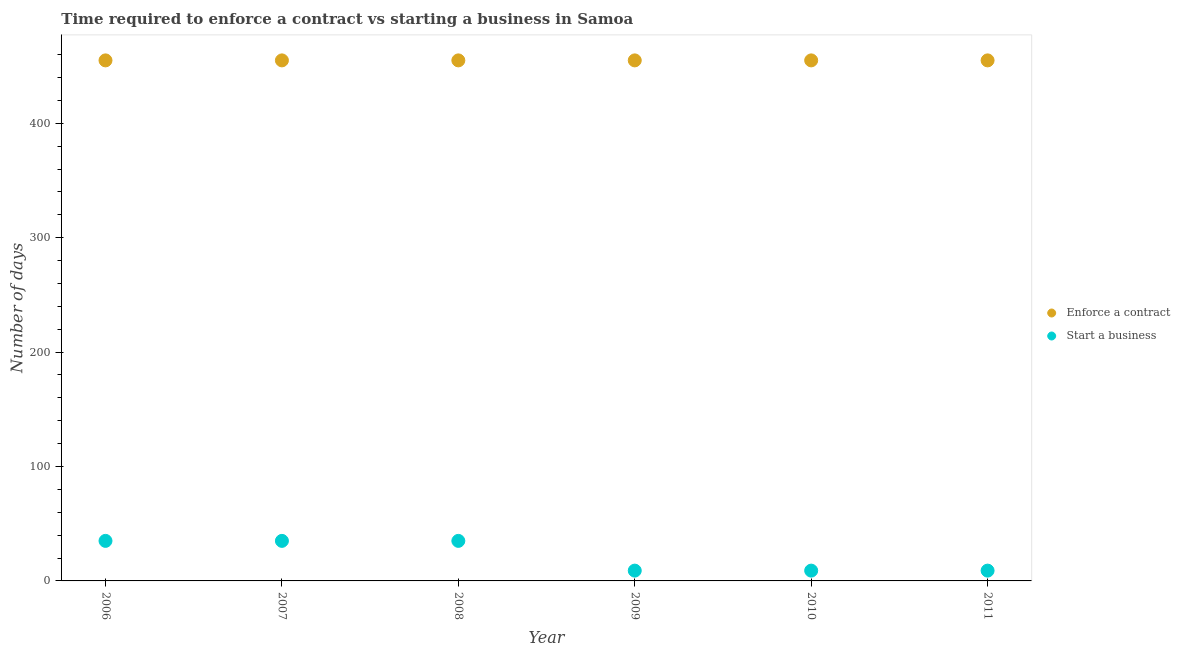How many different coloured dotlines are there?
Your answer should be compact. 2. What is the number of days to start a business in 2011?
Keep it short and to the point. 9. Across all years, what is the maximum number of days to start a business?
Your answer should be compact. 35. Across all years, what is the minimum number of days to enforece a contract?
Provide a short and direct response. 455. In which year was the number of days to enforece a contract maximum?
Provide a succinct answer. 2006. What is the total number of days to start a business in the graph?
Provide a short and direct response. 132. What is the difference between the number of days to enforece a contract in 2011 and the number of days to start a business in 2008?
Give a very brief answer. 420. What is the average number of days to start a business per year?
Your answer should be compact. 22. In the year 2010, what is the difference between the number of days to enforece a contract and number of days to start a business?
Offer a terse response. 446. Is the number of days to enforece a contract in 2009 less than that in 2011?
Your response must be concise. No. What is the difference between the highest and the second highest number of days to enforece a contract?
Provide a succinct answer. 0. What is the difference between the highest and the lowest number of days to start a business?
Give a very brief answer. 26. In how many years, is the number of days to enforece a contract greater than the average number of days to enforece a contract taken over all years?
Your answer should be compact. 0. Does the number of days to start a business monotonically increase over the years?
Your answer should be compact. No. Is the number of days to enforece a contract strictly less than the number of days to start a business over the years?
Provide a short and direct response. No. What is the difference between two consecutive major ticks on the Y-axis?
Your answer should be compact. 100. Where does the legend appear in the graph?
Provide a short and direct response. Center right. How are the legend labels stacked?
Your response must be concise. Vertical. What is the title of the graph?
Offer a very short reply. Time required to enforce a contract vs starting a business in Samoa. What is the label or title of the Y-axis?
Keep it short and to the point. Number of days. What is the Number of days of Enforce a contract in 2006?
Offer a terse response. 455. What is the Number of days in Enforce a contract in 2007?
Offer a terse response. 455. What is the Number of days in Start a business in 2007?
Offer a very short reply. 35. What is the Number of days in Enforce a contract in 2008?
Provide a succinct answer. 455. What is the Number of days of Start a business in 2008?
Make the answer very short. 35. What is the Number of days in Enforce a contract in 2009?
Offer a very short reply. 455. What is the Number of days of Enforce a contract in 2010?
Offer a terse response. 455. What is the Number of days of Start a business in 2010?
Give a very brief answer. 9. What is the Number of days of Enforce a contract in 2011?
Offer a terse response. 455. What is the Number of days in Start a business in 2011?
Provide a short and direct response. 9. Across all years, what is the maximum Number of days of Enforce a contract?
Your response must be concise. 455. Across all years, what is the maximum Number of days in Start a business?
Ensure brevity in your answer.  35. Across all years, what is the minimum Number of days in Enforce a contract?
Give a very brief answer. 455. What is the total Number of days of Enforce a contract in the graph?
Provide a short and direct response. 2730. What is the total Number of days of Start a business in the graph?
Keep it short and to the point. 132. What is the difference between the Number of days of Enforce a contract in 2006 and that in 2008?
Ensure brevity in your answer.  0. What is the difference between the Number of days of Start a business in 2006 and that in 2008?
Keep it short and to the point. 0. What is the difference between the Number of days in Start a business in 2006 and that in 2009?
Your response must be concise. 26. What is the difference between the Number of days of Enforce a contract in 2006 and that in 2010?
Ensure brevity in your answer.  0. What is the difference between the Number of days in Start a business in 2006 and that in 2010?
Your answer should be compact. 26. What is the difference between the Number of days in Enforce a contract in 2006 and that in 2011?
Your answer should be compact. 0. What is the difference between the Number of days in Enforce a contract in 2007 and that in 2008?
Your response must be concise. 0. What is the difference between the Number of days in Start a business in 2007 and that in 2008?
Provide a short and direct response. 0. What is the difference between the Number of days in Start a business in 2007 and that in 2009?
Make the answer very short. 26. What is the difference between the Number of days of Enforce a contract in 2007 and that in 2010?
Make the answer very short. 0. What is the difference between the Number of days in Enforce a contract in 2007 and that in 2011?
Offer a terse response. 0. What is the difference between the Number of days in Start a business in 2008 and that in 2009?
Your answer should be very brief. 26. What is the difference between the Number of days in Enforce a contract in 2008 and that in 2010?
Offer a very short reply. 0. What is the difference between the Number of days in Start a business in 2008 and that in 2010?
Your answer should be very brief. 26. What is the difference between the Number of days in Start a business in 2008 and that in 2011?
Your answer should be very brief. 26. What is the difference between the Number of days in Start a business in 2009 and that in 2010?
Keep it short and to the point. 0. What is the difference between the Number of days in Enforce a contract in 2010 and that in 2011?
Keep it short and to the point. 0. What is the difference between the Number of days in Enforce a contract in 2006 and the Number of days in Start a business in 2007?
Your response must be concise. 420. What is the difference between the Number of days of Enforce a contract in 2006 and the Number of days of Start a business in 2008?
Your answer should be compact. 420. What is the difference between the Number of days in Enforce a contract in 2006 and the Number of days in Start a business in 2009?
Provide a short and direct response. 446. What is the difference between the Number of days in Enforce a contract in 2006 and the Number of days in Start a business in 2010?
Your response must be concise. 446. What is the difference between the Number of days in Enforce a contract in 2006 and the Number of days in Start a business in 2011?
Give a very brief answer. 446. What is the difference between the Number of days of Enforce a contract in 2007 and the Number of days of Start a business in 2008?
Keep it short and to the point. 420. What is the difference between the Number of days in Enforce a contract in 2007 and the Number of days in Start a business in 2009?
Offer a very short reply. 446. What is the difference between the Number of days of Enforce a contract in 2007 and the Number of days of Start a business in 2010?
Give a very brief answer. 446. What is the difference between the Number of days of Enforce a contract in 2007 and the Number of days of Start a business in 2011?
Your response must be concise. 446. What is the difference between the Number of days in Enforce a contract in 2008 and the Number of days in Start a business in 2009?
Ensure brevity in your answer.  446. What is the difference between the Number of days in Enforce a contract in 2008 and the Number of days in Start a business in 2010?
Your response must be concise. 446. What is the difference between the Number of days of Enforce a contract in 2008 and the Number of days of Start a business in 2011?
Your response must be concise. 446. What is the difference between the Number of days in Enforce a contract in 2009 and the Number of days in Start a business in 2010?
Ensure brevity in your answer.  446. What is the difference between the Number of days in Enforce a contract in 2009 and the Number of days in Start a business in 2011?
Make the answer very short. 446. What is the difference between the Number of days of Enforce a contract in 2010 and the Number of days of Start a business in 2011?
Your answer should be very brief. 446. What is the average Number of days in Enforce a contract per year?
Provide a short and direct response. 455. What is the average Number of days in Start a business per year?
Provide a short and direct response. 22. In the year 2006, what is the difference between the Number of days of Enforce a contract and Number of days of Start a business?
Give a very brief answer. 420. In the year 2007, what is the difference between the Number of days of Enforce a contract and Number of days of Start a business?
Your answer should be very brief. 420. In the year 2008, what is the difference between the Number of days in Enforce a contract and Number of days in Start a business?
Provide a short and direct response. 420. In the year 2009, what is the difference between the Number of days in Enforce a contract and Number of days in Start a business?
Offer a terse response. 446. In the year 2010, what is the difference between the Number of days of Enforce a contract and Number of days of Start a business?
Keep it short and to the point. 446. In the year 2011, what is the difference between the Number of days in Enforce a contract and Number of days in Start a business?
Offer a very short reply. 446. What is the ratio of the Number of days in Start a business in 2006 to that in 2007?
Ensure brevity in your answer.  1. What is the ratio of the Number of days of Enforce a contract in 2006 to that in 2008?
Provide a succinct answer. 1. What is the ratio of the Number of days in Enforce a contract in 2006 to that in 2009?
Your answer should be very brief. 1. What is the ratio of the Number of days in Start a business in 2006 to that in 2009?
Ensure brevity in your answer.  3.89. What is the ratio of the Number of days in Enforce a contract in 2006 to that in 2010?
Make the answer very short. 1. What is the ratio of the Number of days in Start a business in 2006 to that in 2010?
Provide a succinct answer. 3.89. What is the ratio of the Number of days in Start a business in 2006 to that in 2011?
Ensure brevity in your answer.  3.89. What is the ratio of the Number of days of Enforce a contract in 2007 to that in 2008?
Offer a terse response. 1. What is the ratio of the Number of days in Start a business in 2007 to that in 2008?
Make the answer very short. 1. What is the ratio of the Number of days in Enforce a contract in 2007 to that in 2009?
Your answer should be very brief. 1. What is the ratio of the Number of days of Start a business in 2007 to that in 2009?
Ensure brevity in your answer.  3.89. What is the ratio of the Number of days in Enforce a contract in 2007 to that in 2010?
Provide a succinct answer. 1. What is the ratio of the Number of days in Start a business in 2007 to that in 2010?
Your response must be concise. 3.89. What is the ratio of the Number of days of Start a business in 2007 to that in 2011?
Ensure brevity in your answer.  3.89. What is the ratio of the Number of days in Enforce a contract in 2008 to that in 2009?
Keep it short and to the point. 1. What is the ratio of the Number of days in Start a business in 2008 to that in 2009?
Offer a terse response. 3.89. What is the ratio of the Number of days of Enforce a contract in 2008 to that in 2010?
Your answer should be compact. 1. What is the ratio of the Number of days of Start a business in 2008 to that in 2010?
Keep it short and to the point. 3.89. What is the ratio of the Number of days in Start a business in 2008 to that in 2011?
Your answer should be very brief. 3.89. What is the ratio of the Number of days in Start a business in 2009 to that in 2010?
Offer a very short reply. 1. What is the ratio of the Number of days of Start a business in 2009 to that in 2011?
Provide a succinct answer. 1. What is the ratio of the Number of days of Enforce a contract in 2010 to that in 2011?
Make the answer very short. 1. What is the ratio of the Number of days of Start a business in 2010 to that in 2011?
Offer a terse response. 1. What is the difference between the highest and the second highest Number of days in Enforce a contract?
Ensure brevity in your answer.  0. What is the difference between the highest and the lowest Number of days of Enforce a contract?
Provide a succinct answer. 0. 